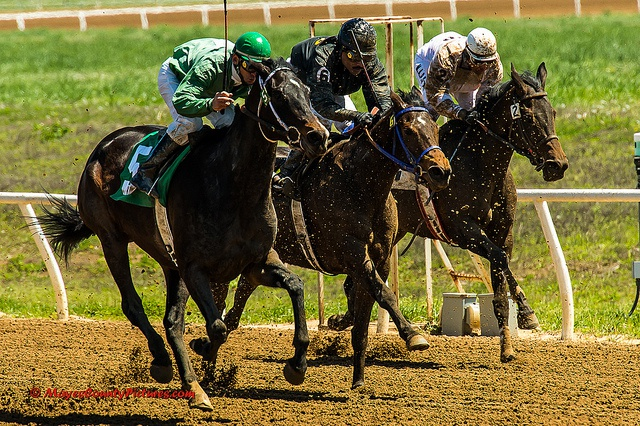Describe the objects in this image and their specific colors. I can see horse in olive, black, gray, and tan tones, horse in olive, black, maroon, and tan tones, horse in olive, black, maroon, and tan tones, people in olive, black, beige, gray, and darkgreen tones, and people in olive, black, gray, darkgray, and ivory tones in this image. 